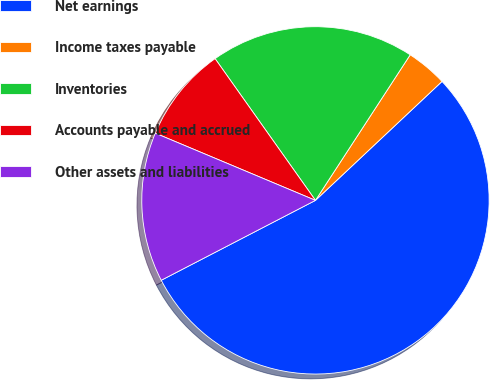Convert chart. <chart><loc_0><loc_0><loc_500><loc_500><pie_chart><fcel>Net earnings<fcel>Income taxes payable<fcel>Inventories<fcel>Accounts payable and accrued<fcel>Other assets and liabilities<nl><fcel>54.4%<fcel>3.81%<fcel>18.99%<fcel>8.87%<fcel>13.93%<nl></chart> 